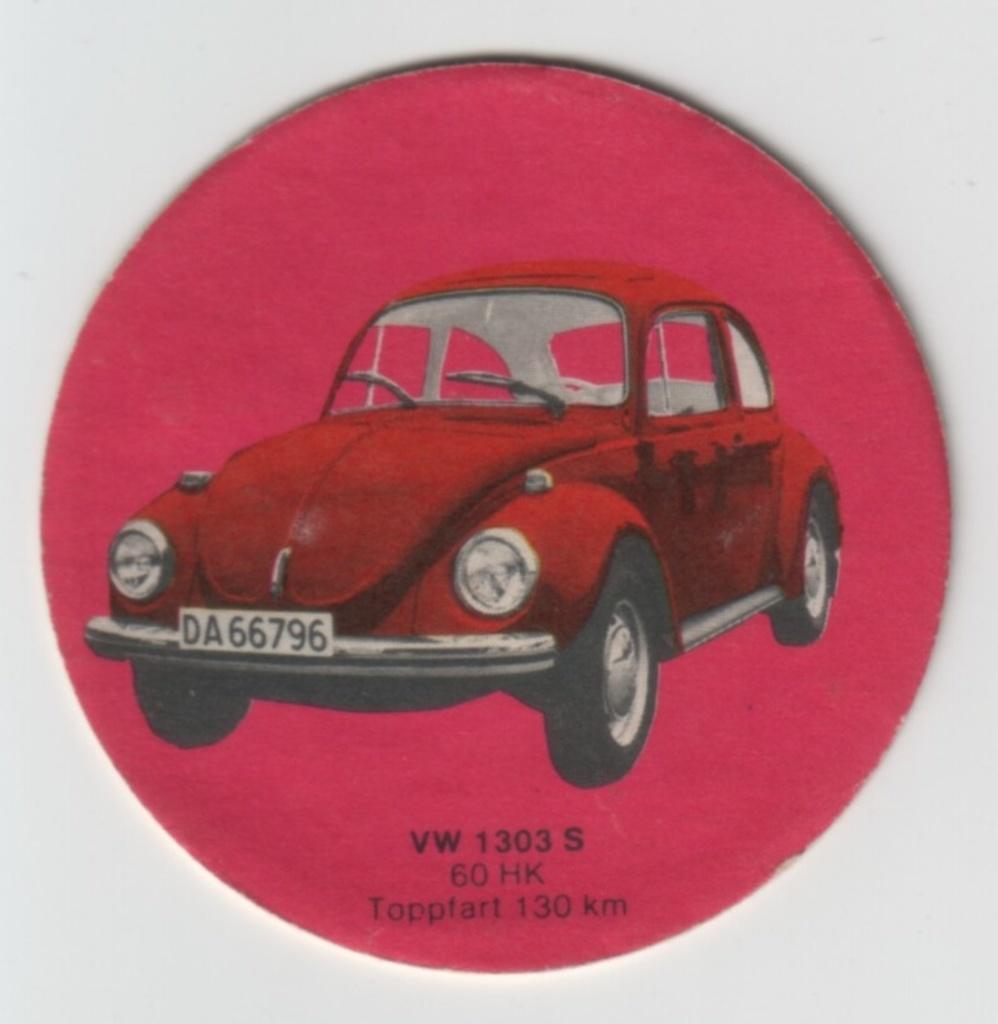Please provide a concise description of this image. In this image I can see a red colour thing and on it I can see depiction picture of a car. I can also see something is written on the bottom side of the thing. 